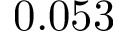Convert formula to latex. <formula><loc_0><loc_0><loc_500><loc_500>0 . 0 5 3</formula> 